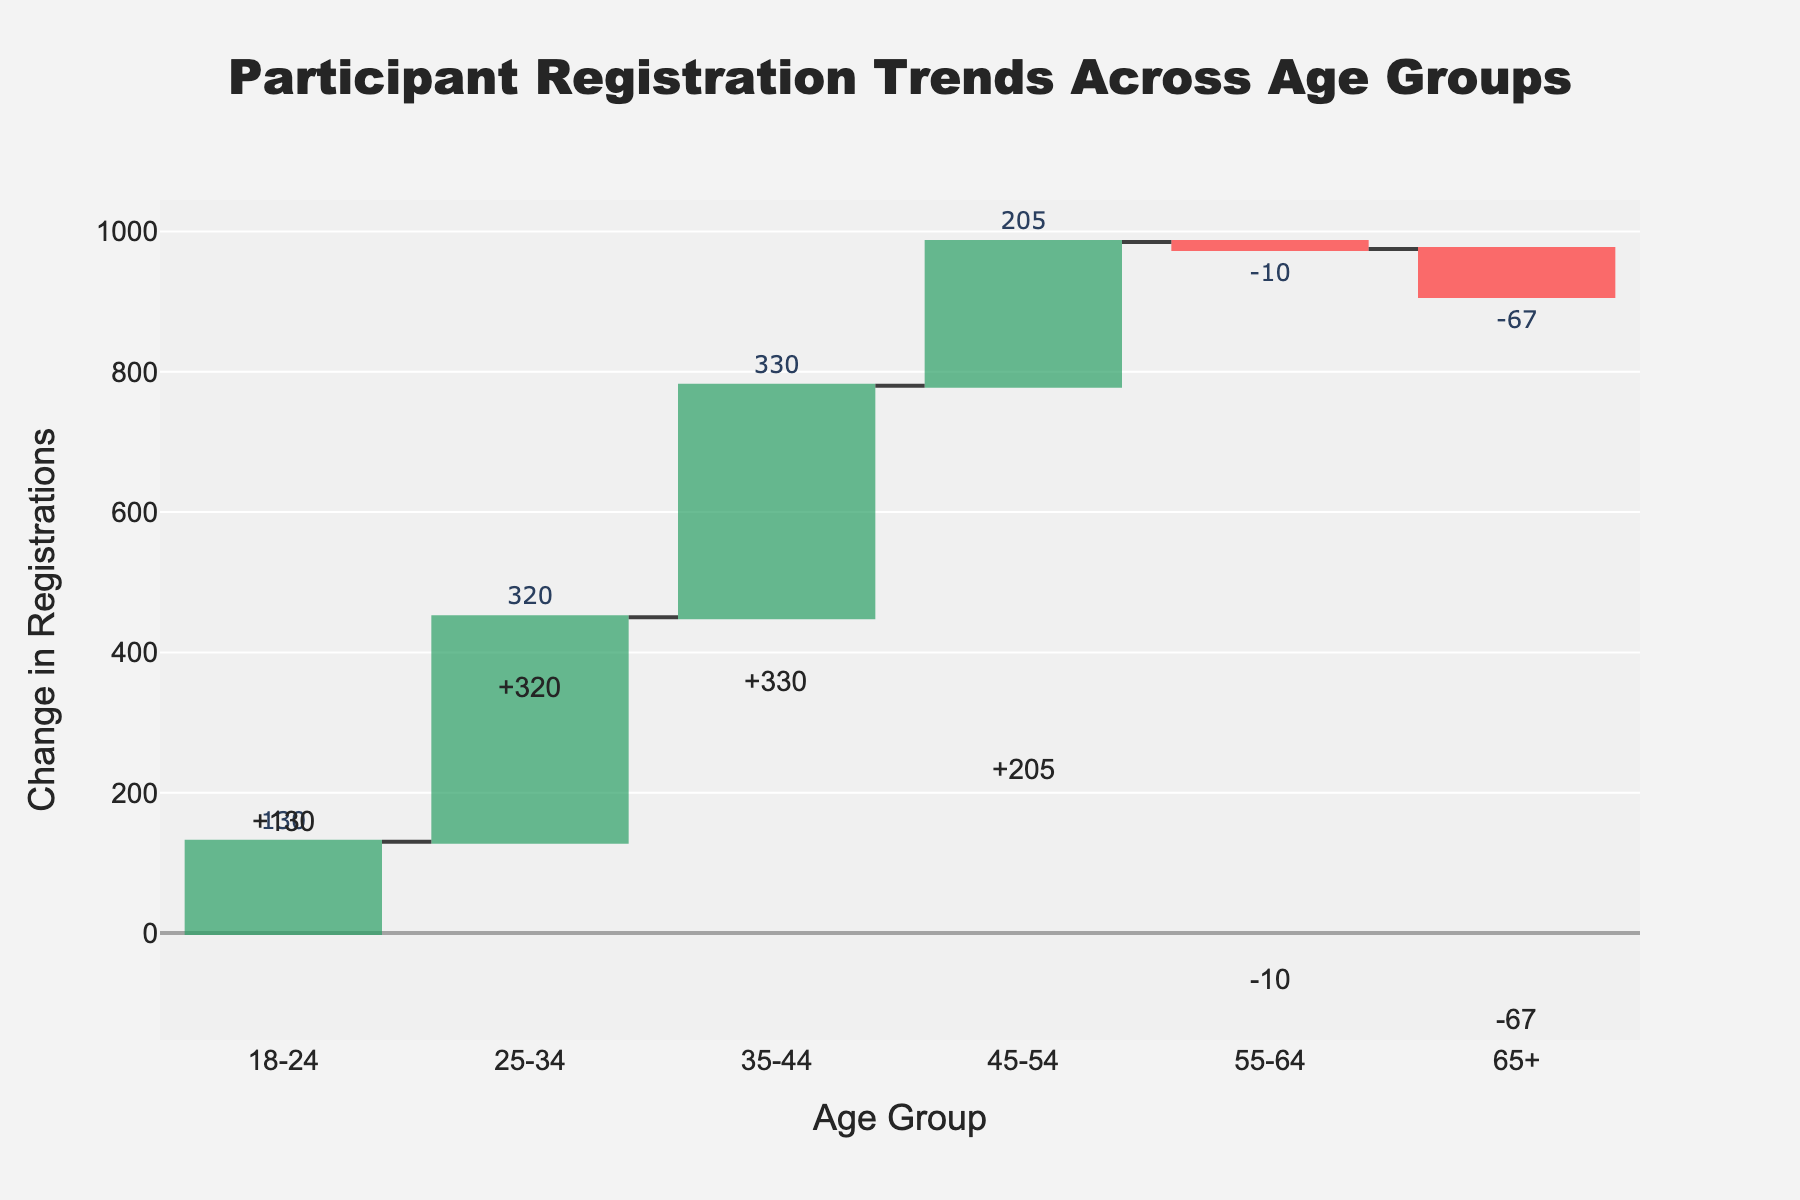What is the title of the figure? The title is located at the top of the chart and is typically one of the most prominent text elements. It reads: "Participant Registration Trends Across Age Groups".
Answer: "Participant Registration Trends Across Age Groups" Which age group has the highest increase in participant registrations? By looking at the height of the bars above the zero line, the "25-34" age group has the highest increase with a value of +320 registrations.
Answer: 25-34 What is the total change in participant registrations for the "55-64" age group? The bar for the "55-64" age group is below the zero line showing a decrease, and it is labeled with a "-10" indicating the total change.
Answer: -10 How many age groups show a decrease in participant registrations? Bars that extend below the zero line indicate a decrease. The age groups "55-64" and "65+" show decreases. Therefore, 2 age groups have a decrease.
Answer: 2 What is the increase in participant registrations for the "35-44" age group? The bar for the "35-44" age group is above the zero line and labeled "+330", indicating an increase of 330 registrations.
Answer: 330 Which event distance contributed the most to the net positive registrations in the "18-24" age group, and what was the value? In the "18-24" group, the "Sprint" event has the highest positive contribution. Referring to the data table, Sprint added +120 registrations.
Answer: Sprint, 120 Compare the total changes in registrations between the age groups "18-24" and "65+". Which one is greater and by how much? The "18-24" group has a total change of +130, and the "65+" group has -67. The difference between +130 and -67 is 197. Therefore, 130 is greater than -67 by 197.
Answer: 18-24, 197 What is the sum of the total changes in registrations for the "45-54" and "55-64" age groups? The total change for "45-54" is +205 and for "55-64" is -10. Adding these together: 205 + (-10) = 195.
Answer: 195 Which age group has the smallest positive change in registrations, and what is the value? Among the positive bars above the zero line, "45-54" has the smallest positive change, labeled +205.
Answer: 45-54, 205 Interpret the trend of participant registrations for the "65+" age group across different event distances. The "65+" age group shows a negative trend in all event distances as each segment in the table ("Sprint": -40, "Olympic": -20, "Half Ironman": -5, "Full Ironman": -2) decreases. The total change is -67 indicating fewer registrations in this age group.
Answer: Decreasing across all events 